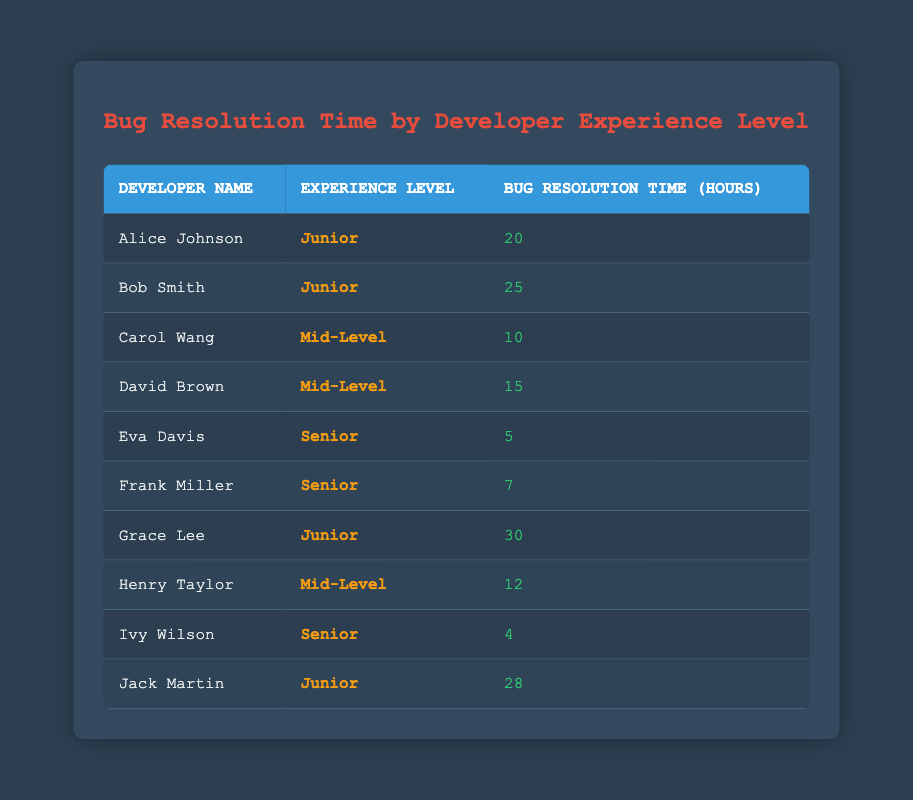What is the bug resolution time of Eva Davis? The table lists the developers along with their bug resolution times. Looking under the row for Eva Davis, we can see that her bug resolution time is 5 hours.
Answer: 5 Which experience level has the highest average bug resolution time? To find the highest average, we calculate the average for each experience level. For Junior: (20 + 25 + 30 + 28)/4 = 25.75 hours; Mid-Level: (10 + 15 + 12)/3 = 12.33 hours; Senior: (5 + 7 + 4)/3 = 5.33 hours. The highest average is 25.75 hours for Junior.
Answer: Junior Is Frank Miller’s bug resolution time greater than the average of all developers? First, sum the bug resolution times: 20 + 25 + 10 + 15 + 5 + 7 + 30 + 12 + 4 + 28 = 156 hours. There are 10 developers, so the average is 156/10 = 15.6 hours. Frank Miller’s time is 7 hours, which is not greater than 15.6 hours.
Answer: No Who has the shortest bug resolution time among Senior developers? The Senior developers are Eva Davis, Frank Miller, and Ivy Wilson. Their respective times are 5, 7, and 4 hours. Among them, Ivy Wilson has the shortest time of 4 hours.
Answer: Ivy Wilson What is the total bug resolution time for Junior developers? The Junior developers are Alice Johnson, Bob Smith, Grace Lee, and Jack Martin. Their times are 20, 25, 30, and 28 hours respectively. Summing these gives: 20 + 25 + 30 + 28 = 103 hours.
Answer: 103 What is the difference in bug resolution time between the fastest Mid-Level developer and the fastest Junior developer? The fastest Mid-Level developer is Carol Wang with 10 hours, and the fastest Junior developer is Alice Johnson with 20 hours. The difference is 20 - 10 = 10 hours.
Answer: 10 